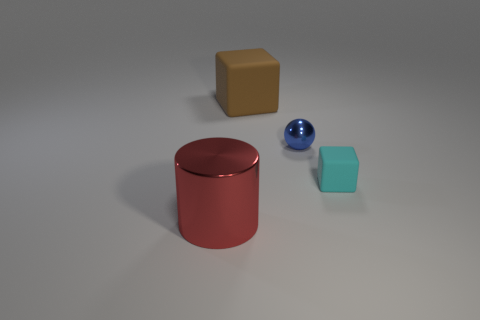Subtract all cyan cubes. How many cubes are left? 1 Subtract all cylinders. How many objects are left? 3 Subtract 1 blocks. How many blocks are left? 1 Add 2 big cylinders. How many objects exist? 6 Subtract all cyan blocks. Subtract all yellow cylinders. How many blocks are left? 1 Subtract all yellow cylinders. How many brown blocks are left? 1 Subtract all tiny blue balls. Subtract all red cylinders. How many objects are left? 2 Add 2 brown cubes. How many brown cubes are left? 3 Add 2 shiny objects. How many shiny objects exist? 4 Subtract 0 blue cylinders. How many objects are left? 4 